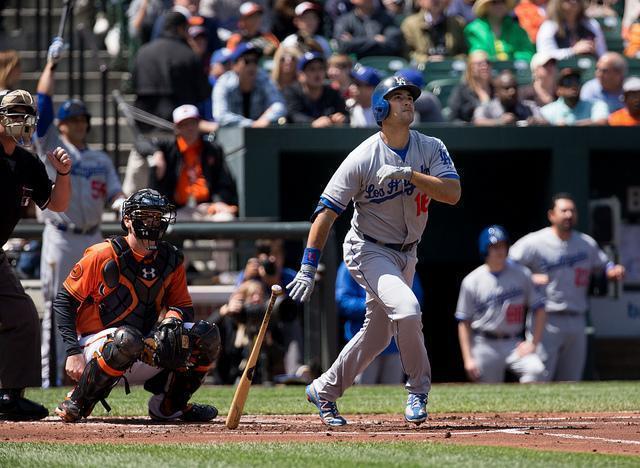The player just hit the ball so he watches it while he runs to what base?
Indicate the correct response by choosing from the four available options to answer the question.
Options: Second, home, first, fourth. First. 